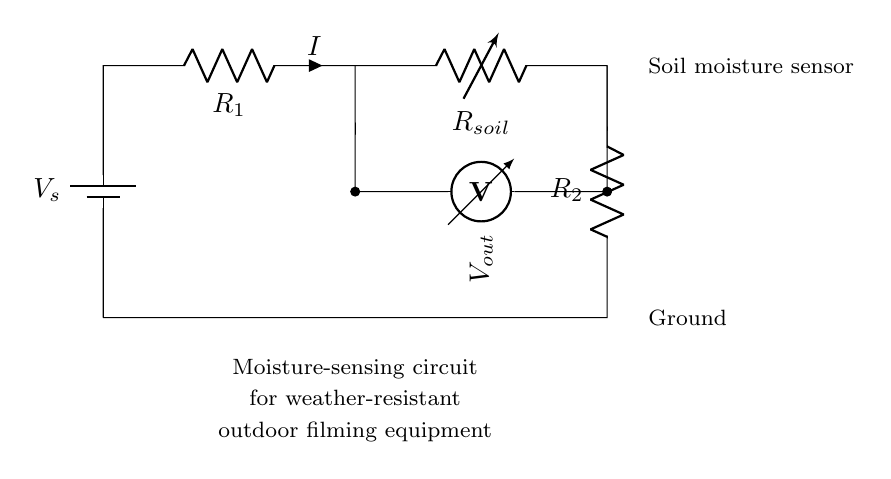What type of sensor is depicted in the circuit? The circuit includes a soil moisture sensor, which is usually designed to detect moisture levels in the soil. This is indicated by the labeling next to the variable resistor.
Answer: soil moisture sensor What component is labeled as R1? R1 is referred to as a resistor in the circuit. This component is responsible for limiting current and can be identified in the diagram based on the labeling.
Answer: resistor How many resistors are present in the circuit? The circuit shows two resistors: R1 and R2. This can be counted directly on the diagram, where each resistor is distinctly labeled.
Answer: two What is the purpose of the variable resistor in the circuit? The variable resistor, labeled as R soil, adjusts the resistance or sensitivity of the moisture sensor, allowing for calibration based on environmental conditions.
Answer: calibration What does Vout represent in this circuit? Vout signifies the output voltage from the circuit, which is measured across the location where R soil and R2 connect. It indicates the moisture level detected by the sensor.
Answer: output voltage If the soil moisture is high, what would you expect for Vout? A high soil moisture level would typically result in a higher output voltage, as the resistance of the soil sensor decreases with increased moisture content. Thus, it affects the voltage reading observed at Vout.
Answer: higher output voltage 